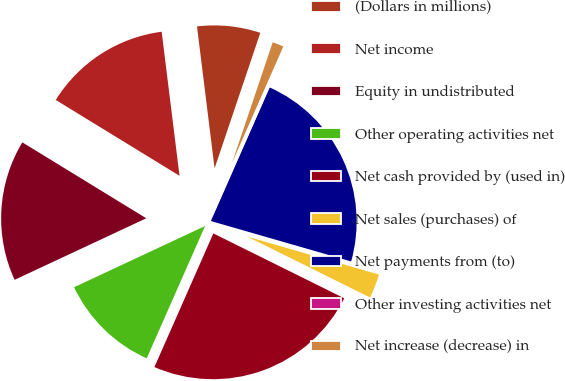Convert chart. <chart><loc_0><loc_0><loc_500><loc_500><pie_chart><fcel>(Dollars in millions)<fcel>Net income<fcel>Equity in undistributed<fcel>Other operating activities net<fcel>Net cash provided by (used in)<fcel>Net sales (purchases) of<fcel>Net payments from (to)<fcel>Other investing activities net<fcel>Net increase (decrease) in<nl><fcel>7.14%<fcel>14.29%<fcel>15.71%<fcel>11.43%<fcel>24.29%<fcel>2.86%<fcel>22.86%<fcel>0.0%<fcel>1.43%<nl></chart> 